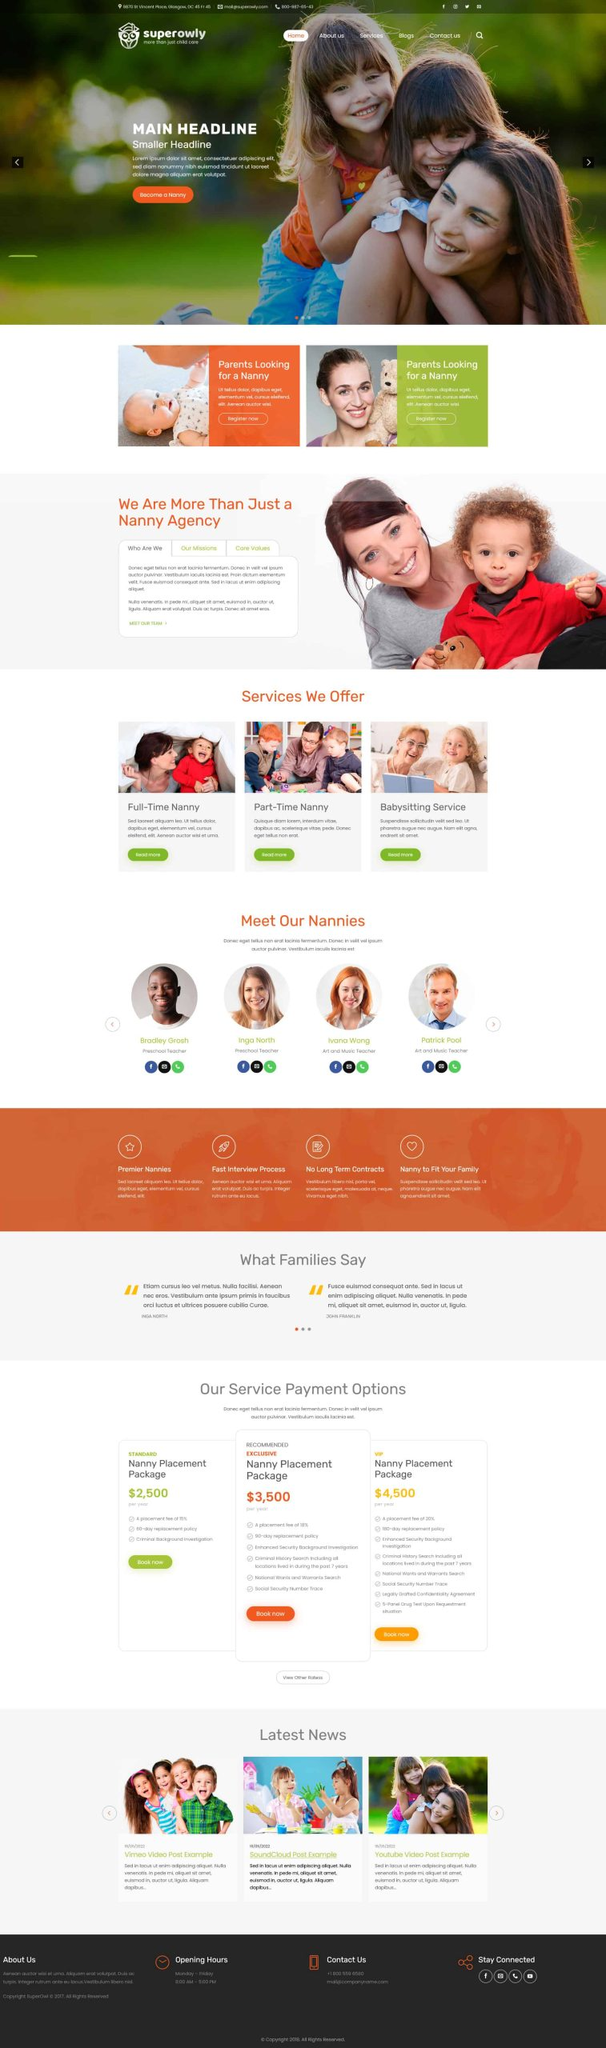Liệt kê 5 ngành nghề, lĩnh vực phù hợp với website này, phân cách các màu sắc bằng dấu phẩy. Chỉ trả về kết quả, phân cách bằng dấy phẩy
 Chăm sóc trẻ em, Dịch vụ trông trẻ, Giới thiệu bảo mẫu, Đào tạo bảo mẫu, Tư vấn gia đình 